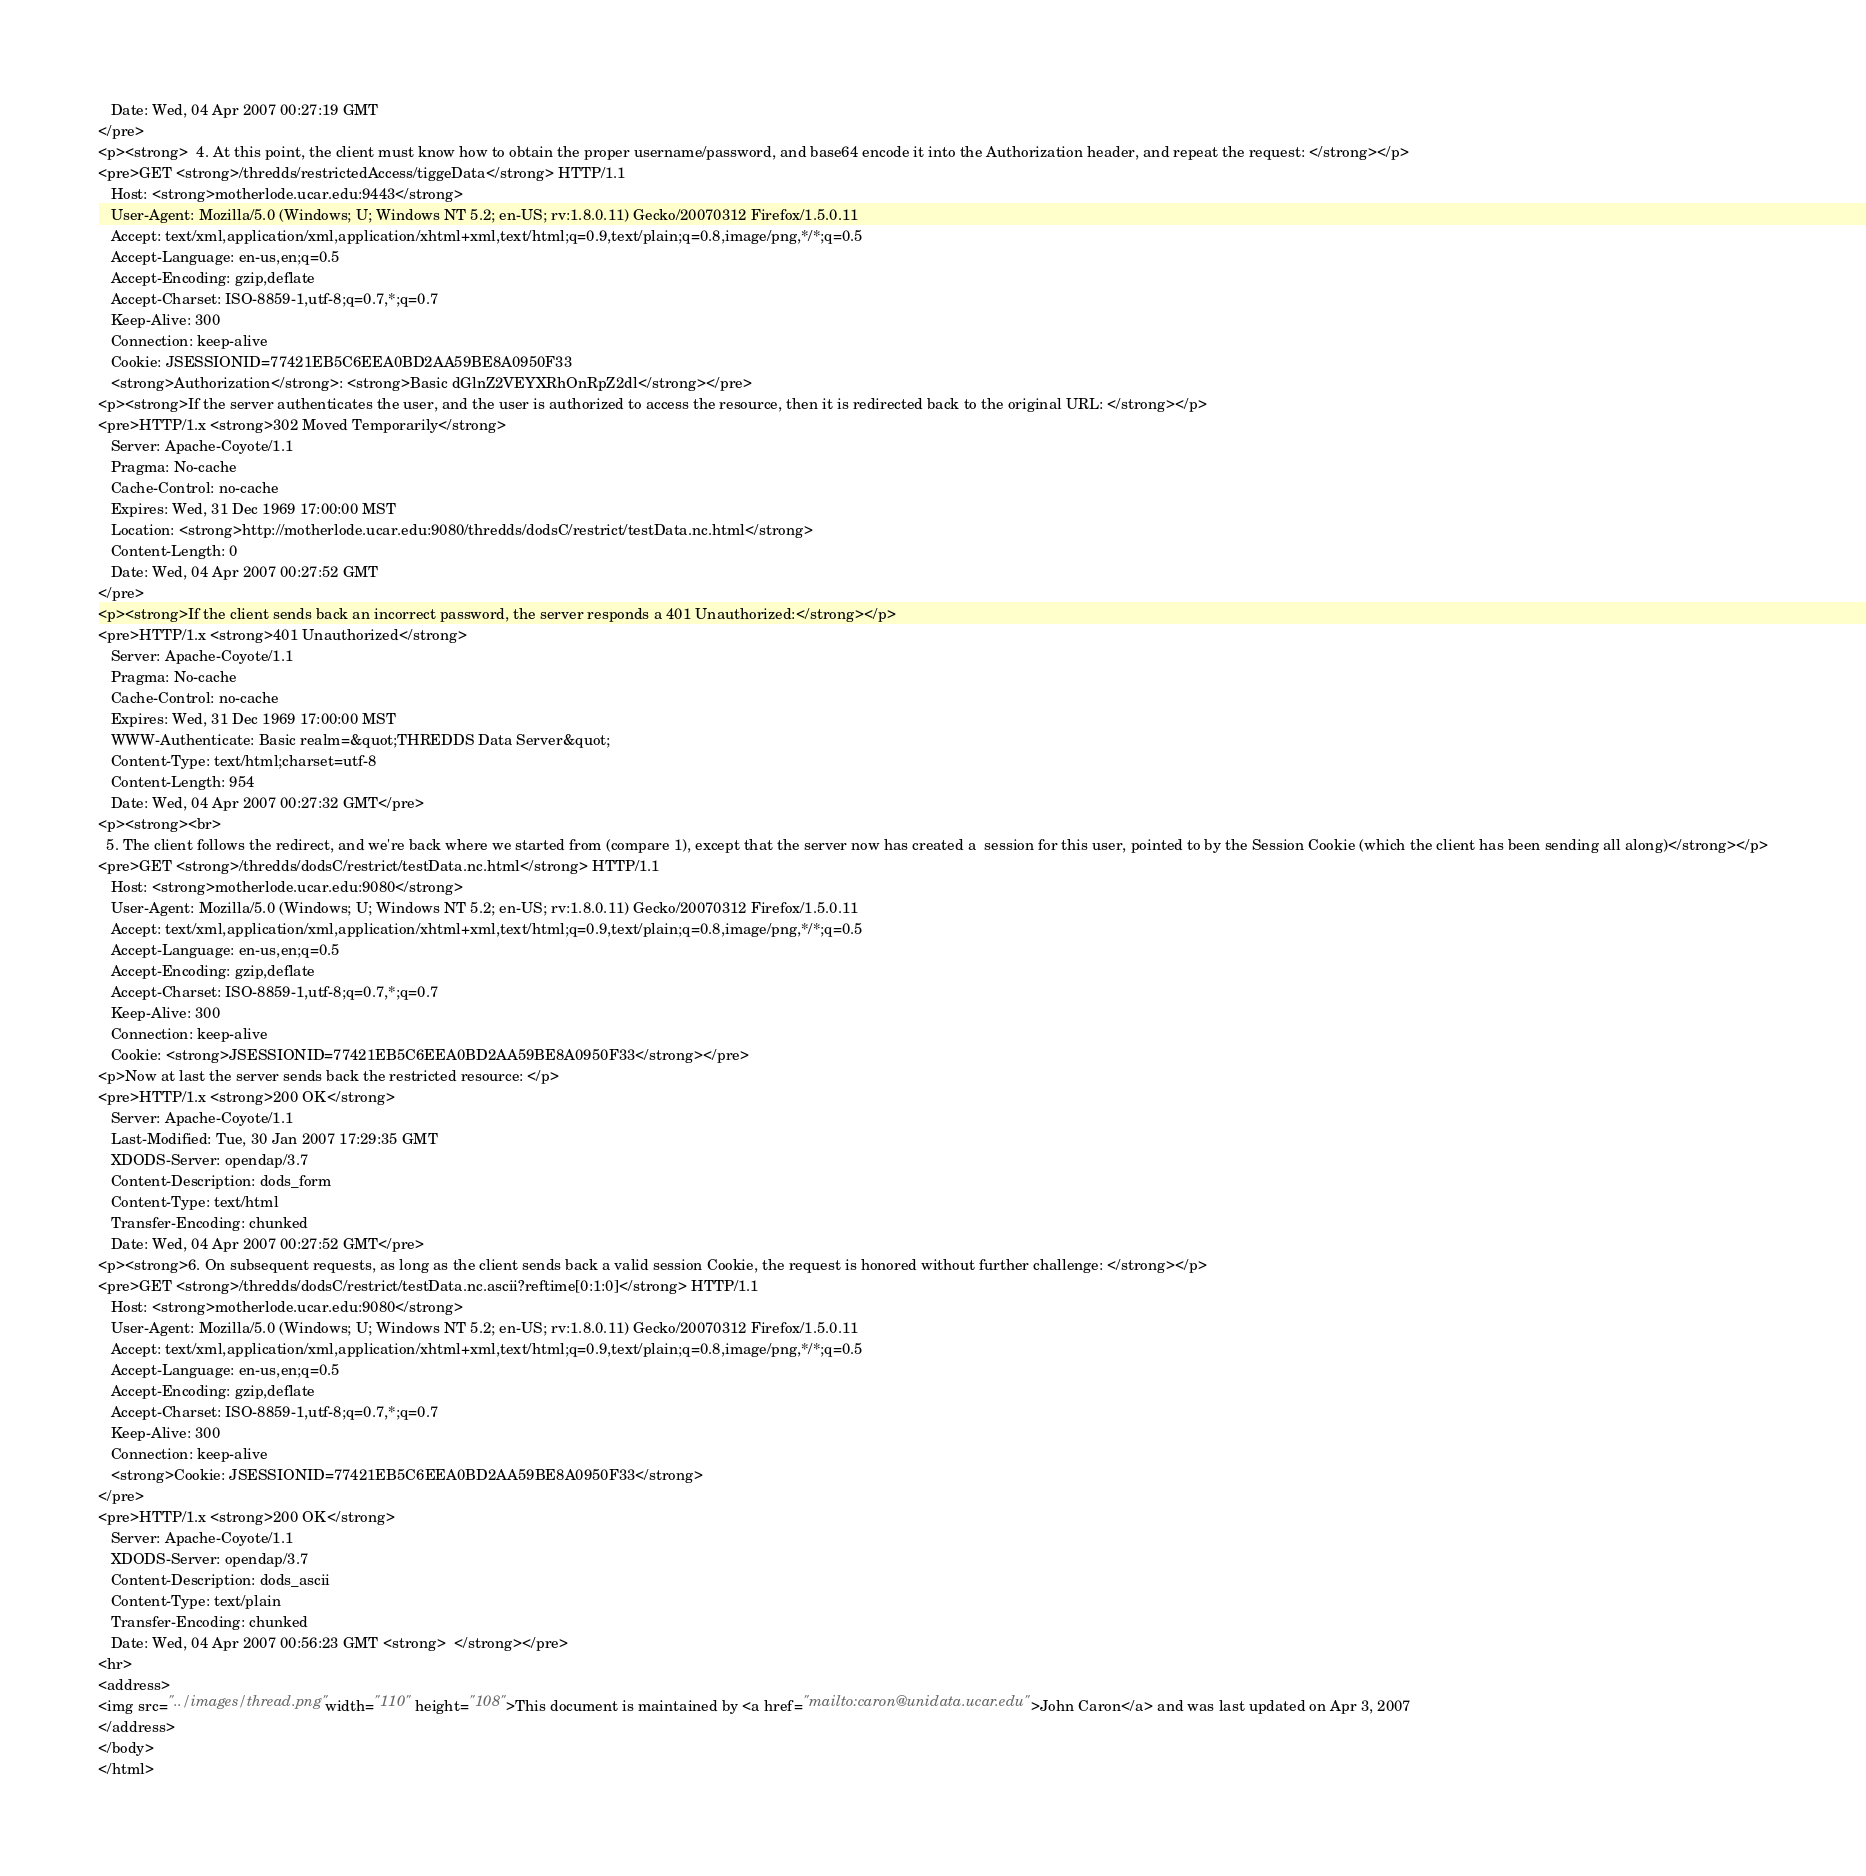Convert code to text. <code><loc_0><loc_0><loc_500><loc_500><_HTML_>   Date: Wed, 04 Apr 2007 00:27:19 GMT
</pre>
<p><strong>  4. At this point, the client must know how to obtain the proper username/password, and base64 encode it into the Authorization header, and repeat the request: </strong></p>
<pre>GET <strong>/thredds/restrictedAccess/tiggeData</strong> HTTP/1.1
   Host: <strong>motherlode.ucar.edu:9443</strong>
   User-Agent: Mozilla/5.0 (Windows; U; Windows NT 5.2; en-US; rv:1.8.0.11) Gecko/20070312 Firefox/1.5.0.11
   Accept: text/xml,application/xml,application/xhtml+xml,text/html;q=0.9,text/plain;q=0.8,image/png,*/*;q=0.5
   Accept-Language: en-us,en;q=0.5
   Accept-Encoding: gzip,deflate
   Accept-Charset: ISO-8859-1,utf-8;q=0.7,*;q=0.7
   Keep-Alive: 300
   Connection: keep-alive
   Cookie: JSESSIONID=77421EB5C6EEA0BD2AA59BE8A0950F33
   <strong>Authorization</strong>: <strong>Basic dGlnZ2VEYXRhOnRpZ2dl</strong></pre>
<p><strong>If the server authenticates the user, and the user is authorized to access the resource, then it is redirected back to the original URL: </strong></p>
<pre>HTTP/1.x <strong>302 Moved Temporarily</strong>
   Server: Apache-Coyote/1.1
   Pragma: No-cache
   Cache-Control: no-cache
   Expires: Wed, 31 Dec 1969 17:00:00 MST
   Location: <strong>http://motherlode.ucar.edu:9080/thredds/dodsC/restrict/testData.nc.html</strong>
   Content-Length: 0
   Date: Wed, 04 Apr 2007 00:27:52 GMT
</pre>
<p><strong>If the client sends back an incorrect password, the server responds a 401 Unauthorized:</strong></p>
<pre>HTTP/1.x <strong>401 Unauthorized</strong>
   Server: Apache-Coyote/1.1
   Pragma: No-cache
   Cache-Control: no-cache
   Expires: Wed, 31 Dec 1969 17:00:00 MST
   WWW-Authenticate: Basic realm=&quot;THREDDS Data Server&quot;
   Content-Type: text/html;charset=utf-8
   Content-Length: 954
   Date: Wed, 04 Apr 2007 00:27:32 GMT</pre>
<p><strong><br>
  5. The client follows the redirect, and we're back where we started from (compare 1), except that the server now has created a  session for this user, pointed to by the Session Cookie (which the client has been sending all along)</strong></p>
<pre>GET <strong>/thredds/dodsC/restrict/testData.nc.html</strong> HTTP/1.1
   Host: <strong>motherlode.ucar.edu:9080</strong>
   User-Agent: Mozilla/5.0 (Windows; U; Windows NT 5.2; en-US; rv:1.8.0.11) Gecko/20070312 Firefox/1.5.0.11
   Accept: text/xml,application/xml,application/xhtml+xml,text/html;q=0.9,text/plain;q=0.8,image/png,*/*;q=0.5
   Accept-Language: en-us,en;q=0.5
   Accept-Encoding: gzip,deflate
   Accept-Charset: ISO-8859-1,utf-8;q=0.7,*;q=0.7
   Keep-Alive: 300
   Connection: keep-alive
   Cookie: <strong>JSESSIONID=77421EB5C6EEA0BD2AA59BE8A0950F33</strong></pre>
<p>Now at last the server sends back the restricted resource: </p>
<pre>HTTP/1.x <strong>200 OK</strong>
   Server: Apache-Coyote/1.1
   Last-Modified: Tue, 30 Jan 2007 17:29:35 GMT
   XDODS-Server: opendap/3.7
   Content-Description: dods_form
   Content-Type: text/html
   Transfer-Encoding: chunked
   Date: Wed, 04 Apr 2007 00:27:52 GMT</pre>
<p><strong>6. On subsequent requests, as long as the client sends back a valid session Cookie, the request is honored without further challenge: </strong></p>
<pre>GET <strong>/thredds/dodsC/restrict/testData.nc.ascii?reftime[0:1:0]</strong> HTTP/1.1
   Host: <strong>motherlode.ucar.edu:9080</strong>
   User-Agent: Mozilla/5.0 (Windows; U; Windows NT 5.2; en-US; rv:1.8.0.11) Gecko/20070312 Firefox/1.5.0.11
   Accept: text/xml,application/xml,application/xhtml+xml,text/html;q=0.9,text/plain;q=0.8,image/png,*/*;q=0.5
   Accept-Language: en-us,en;q=0.5
   Accept-Encoding: gzip,deflate
   Accept-Charset: ISO-8859-1,utf-8;q=0.7,*;q=0.7
   Keep-Alive: 300
   Connection: keep-alive
   <strong>Cookie: JSESSIONID=77421EB5C6EEA0BD2AA59BE8A0950F33</strong>
</pre>
<pre>HTTP/1.x <strong>200 OK</strong>
   Server: Apache-Coyote/1.1
   XDODS-Server: opendap/3.7
   Content-Description: dods_ascii
   Content-Type: text/plain
   Transfer-Encoding: chunked
   Date: Wed, 04 Apr 2007 00:56:23 GMT <strong>  </strong></pre>
<hr>
<address>
<img src="../images/thread.png" width="110" height="108">This document is maintained by <a href="mailto:caron@unidata.ucar.edu">John Caron</a> and was last updated on Apr 3, 2007
</address>
</body>
</html>
</code> 